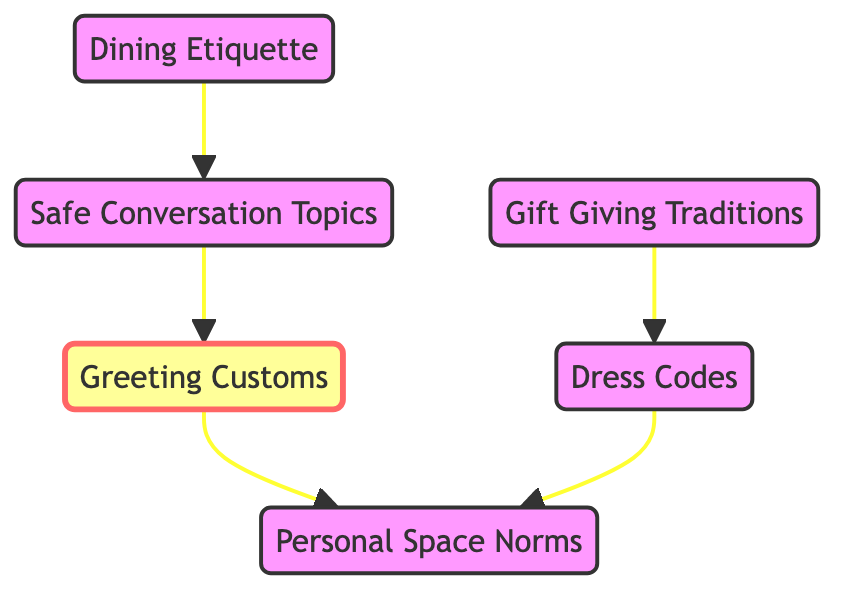What are the main nodes in this diagram? The diagram contains six nodes: Greeting Customs, Dining Etiquette, Personal Space Norms, Gift Giving Traditions, Dress Codes, and Safe Conversation Topics.
Answer: Greeting Customs, Dining Etiquette, Personal Space Norms, Gift Giving Traditions, Dress Codes, Safe Conversation Topics How many edges are there in the diagram? By counting the lines connecting the nodes, we find there are five edges in total connecting various nodes with directed arrows.
Answer: 5 Which node is directly connected to "Gift Giving Traditions"? The edge going from "Gift Giving Traditions" points directly to "Dress Codes", indicating that "Dress Codes" is the node connected to it.
Answer: Dress Codes What is the relationship between "Dining Etiquette" and "Safe Conversation Topics"? "Dining Etiquette" has an outgoing edge that connects to "Safe Conversation Topics", indicating a direct influence or connection from "Dining Etiquette" to this node.
Answer: Direct connection Which two nodes are interconnected through "Personal Space Norms"? "Greeting Customs" and "Dress Codes" are both connected to "Personal Space Norms", indicating that they relate to it through their own specific paths.
Answer: Greeting Customs, Dress Codes What sequence is followed from "Conversation Topics" back to "Greeting Customs"? The flow goes from "Conversation Topics" to "Greeting Customs", meaning that after discussing safe conversation topics, one might return to the greeting customs aspect.
Answer: Conversation Topics to Greeting Customs Which node influences "Personal Space Norms"? Both "Greeting Customs" and "Dress Codes" influence "Personal Space Norms" as they have directed edges that lead to it.
Answer: Greeting Customs, Dress Codes How does "Gift Giving Traditions" influence "Dress Codes"? "Gift Giving Traditions" has a direct edge leading to "Dress Codes", suggesting that the customs surrounding gift giving impact the expected dress code.
Answer: Direct influence What is the main focus of this diagram? The diagram focuses on cultural etiquette by showing various customs and traditions related to social interactions and behaviors among different cultures.
Answer: Cultural etiquette 